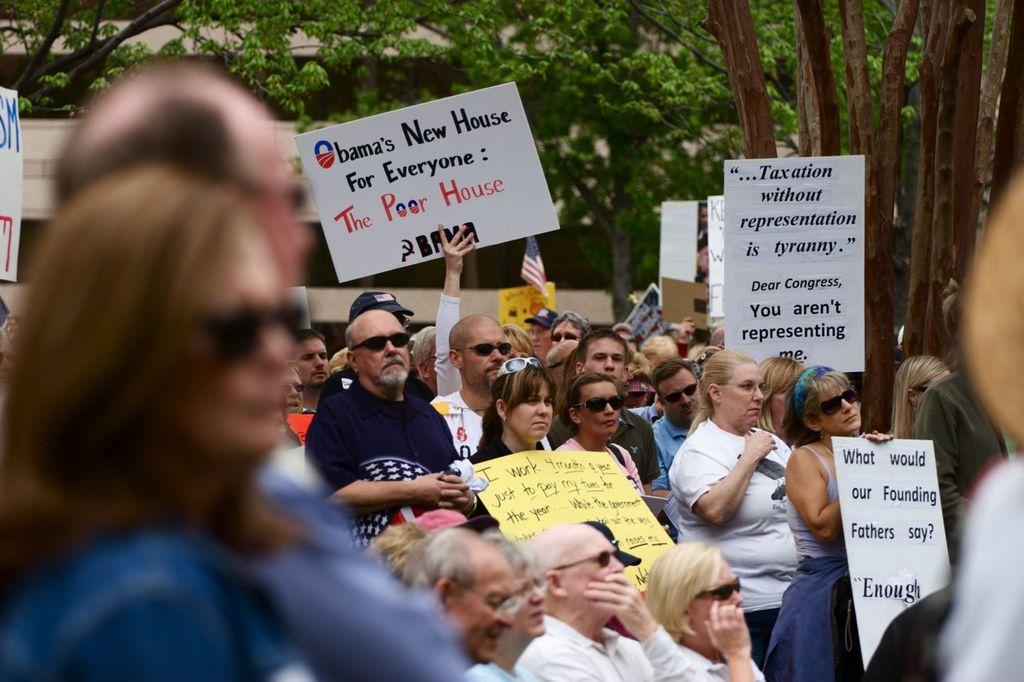Please provide a concise description of this image. In this image I can see a group of people are holding boards in their hand are standing on the road. In the background I can see trees, buildings and so on. This image is taken may be on the road. 